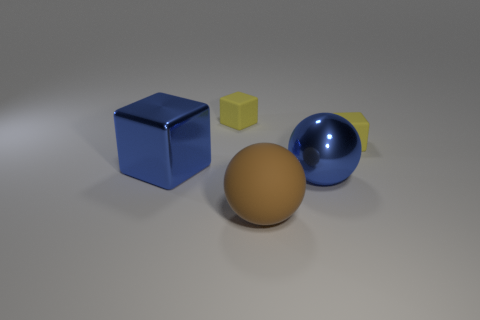Add 4 large blue objects. How many objects exist? 9 Subtract all balls. How many objects are left? 3 Subtract all large metal balls. Subtract all brown rubber things. How many objects are left? 3 Add 2 big objects. How many big objects are left? 5 Add 3 big metallic cubes. How many big metallic cubes exist? 4 Subtract 0 brown cubes. How many objects are left? 5 